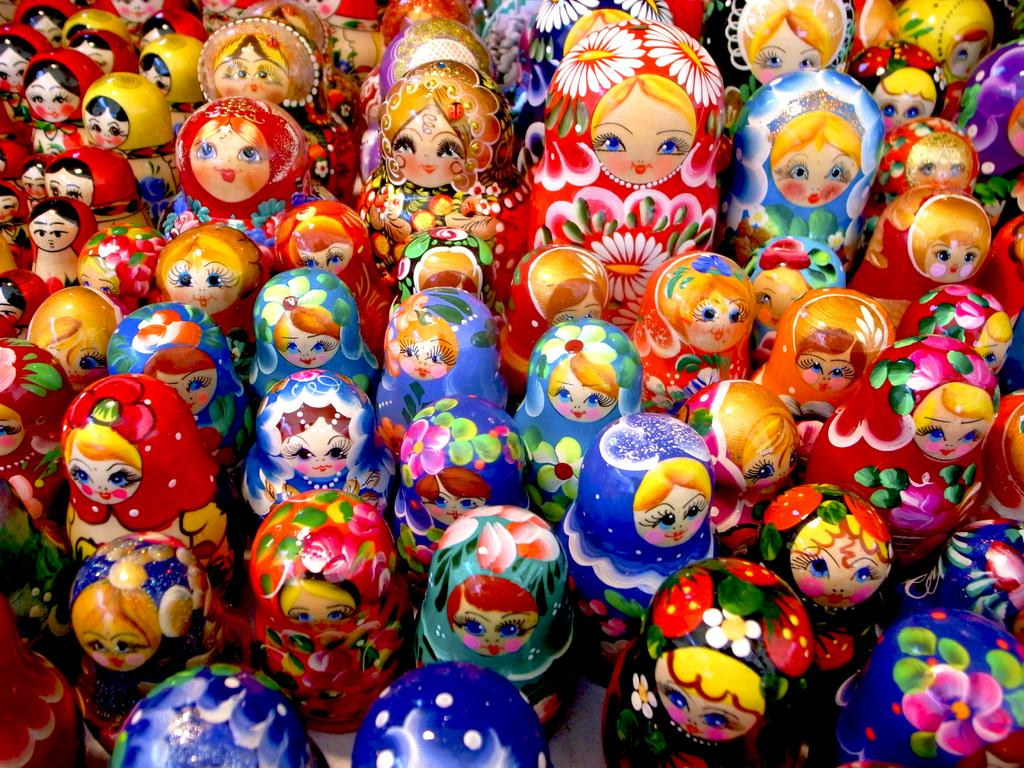What type of dolls are present in the image? There are wooden painted dolls in the image. Who is the secretary of the wooden painted dolls in the image? There is no indication in the image that the wooden painted dolls have a secretary or any human-like roles or relationships. 